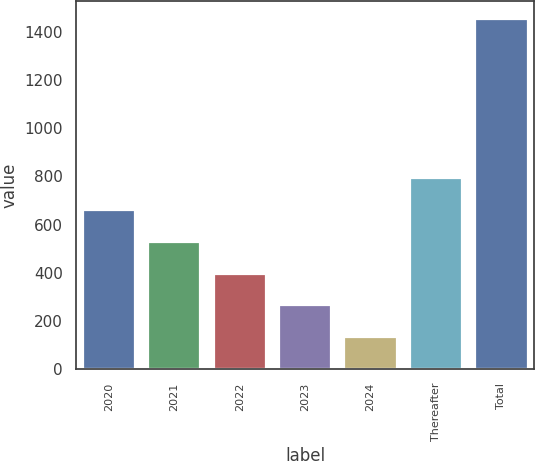Convert chart to OTSL. <chart><loc_0><loc_0><loc_500><loc_500><bar_chart><fcel>2020<fcel>2021<fcel>2022<fcel>2023<fcel>2024<fcel>Thereafter<fcel>Total<nl><fcel>661.2<fcel>529.2<fcel>397.2<fcel>265.2<fcel>133.2<fcel>793.2<fcel>1453.2<nl></chart> 